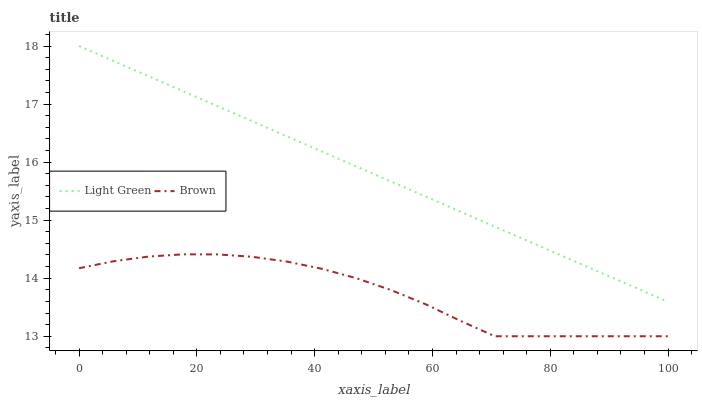Does Light Green have the minimum area under the curve?
Answer yes or no. No. Is Light Green the roughest?
Answer yes or no. No. Does Light Green have the lowest value?
Answer yes or no. No. Is Brown less than Light Green?
Answer yes or no. Yes. Is Light Green greater than Brown?
Answer yes or no. Yes. Does Brown intersect Light Green?
Answer yes or no. No. 